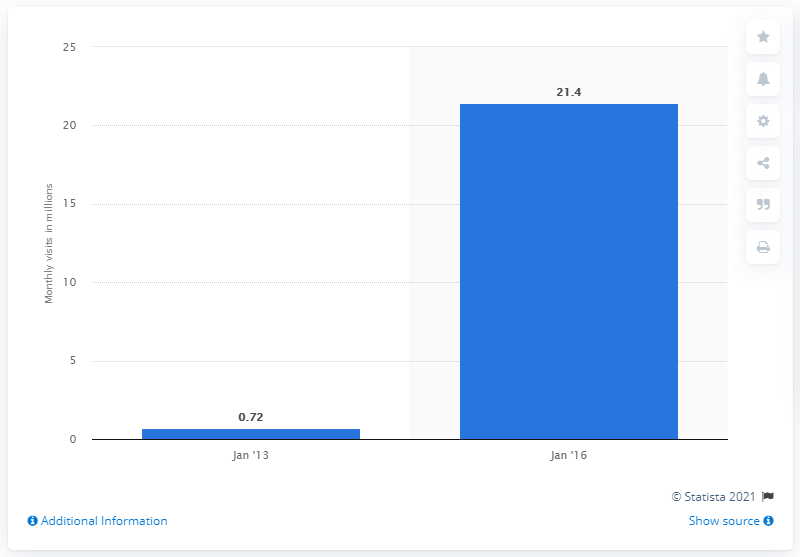Highlight a few significant elements in this photo. As of January 2016, it is estimated that 21.4 subscription retail sites in the U.S. were visited. 